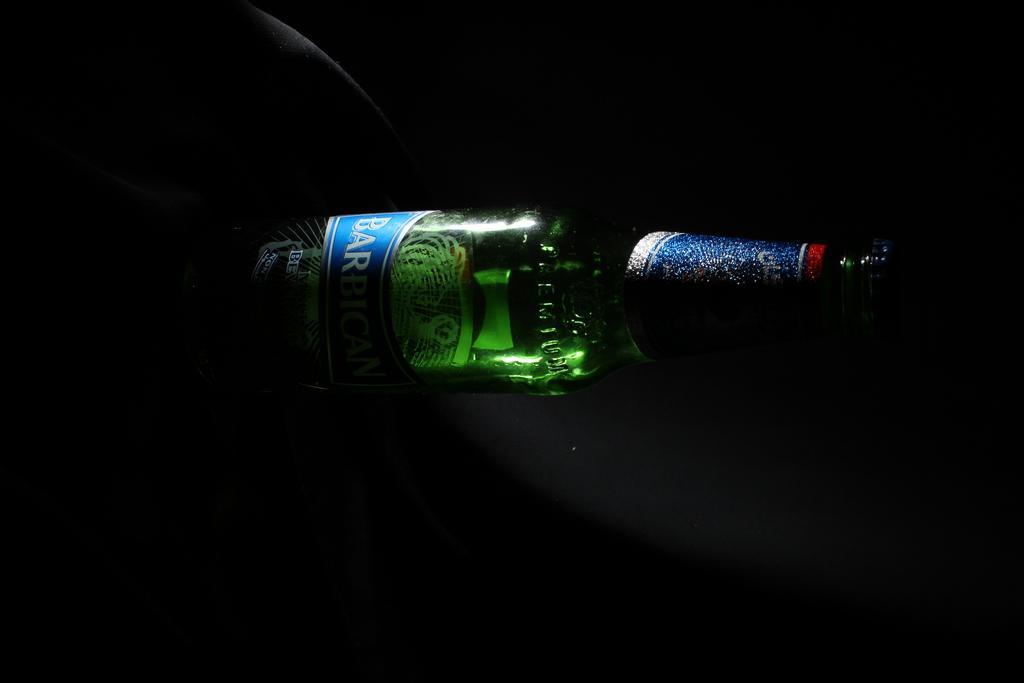Could you give a brief overview of what you see in this image? This is the image of a wine bottle. 